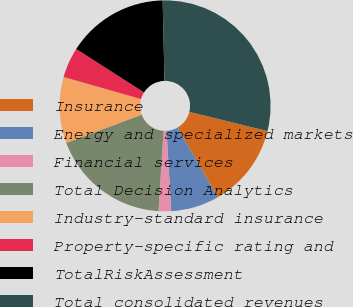Convert chart. <chart><loc_0><loc_0><loc_500><loc_500><pie_chart><fcel>Insurance<fcel>Energy and specialized markets<fcel>Financial services<fcel>Total Decision Analytics<fcel>Industry-standard insurance<fcel>Property-specific rating and<fcel>TotalRiskAssessment<fcel>Total consolidated revenues<nl><fcel>12.84%<fcel>7.39%<fcel>1.93%<fcel>18.3%<fcel>10.11%<fcel>4.66%<fcel>15.57%<fcel>29.2%<nl></chart> 